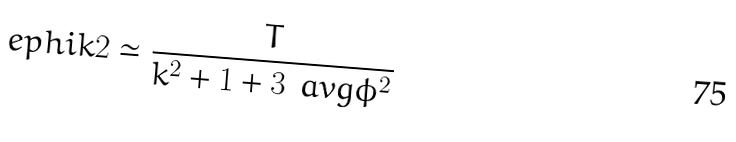<formula> <loc_0><loc_0><loc_500><loc_500>\ e p h i k 2 \simeq \frac { T } { k ^ { 2 } + 1 + 3 \, \ a v g { \phi ^ { 2 } } }</formula> 